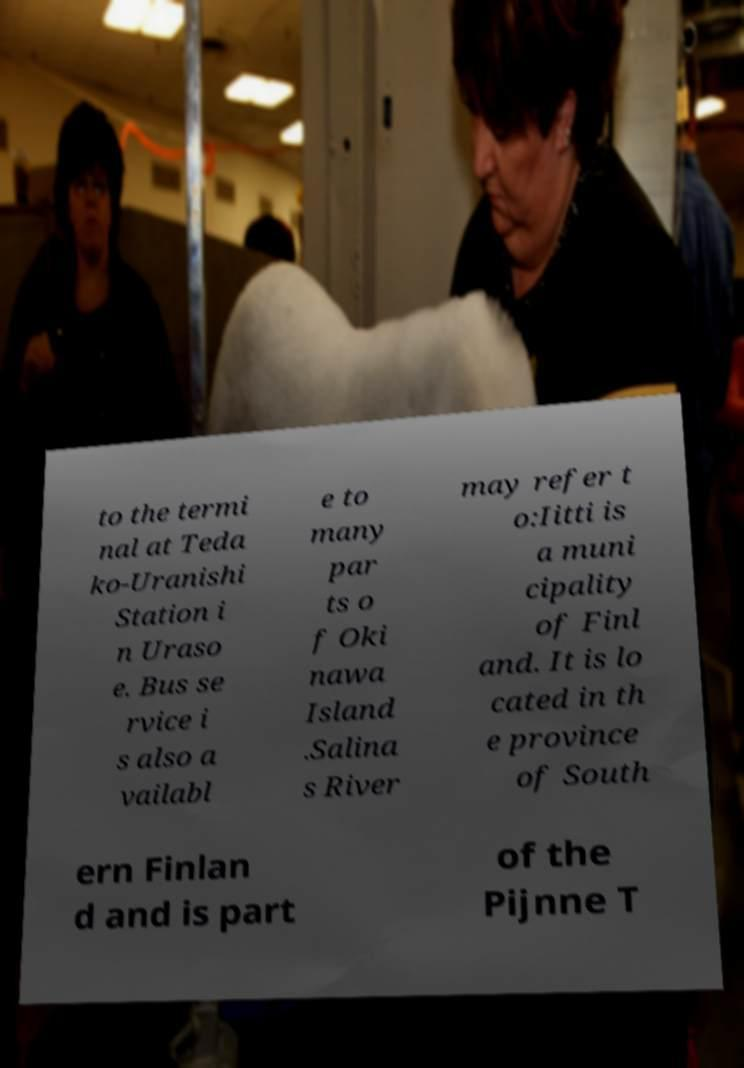Please identify and transcribe the text found in this image. to the termi nal at Teda ko-Uranishi Station i n Uraso e. Bus se rvice i s also a vailabl e to many par ts o f Oki nawa Island .Salina s River may refer t o:Iitti is a muni cipality of Finl and. It is lo cated in th e province of South ern Finlan d and is part of the Pijnne T 